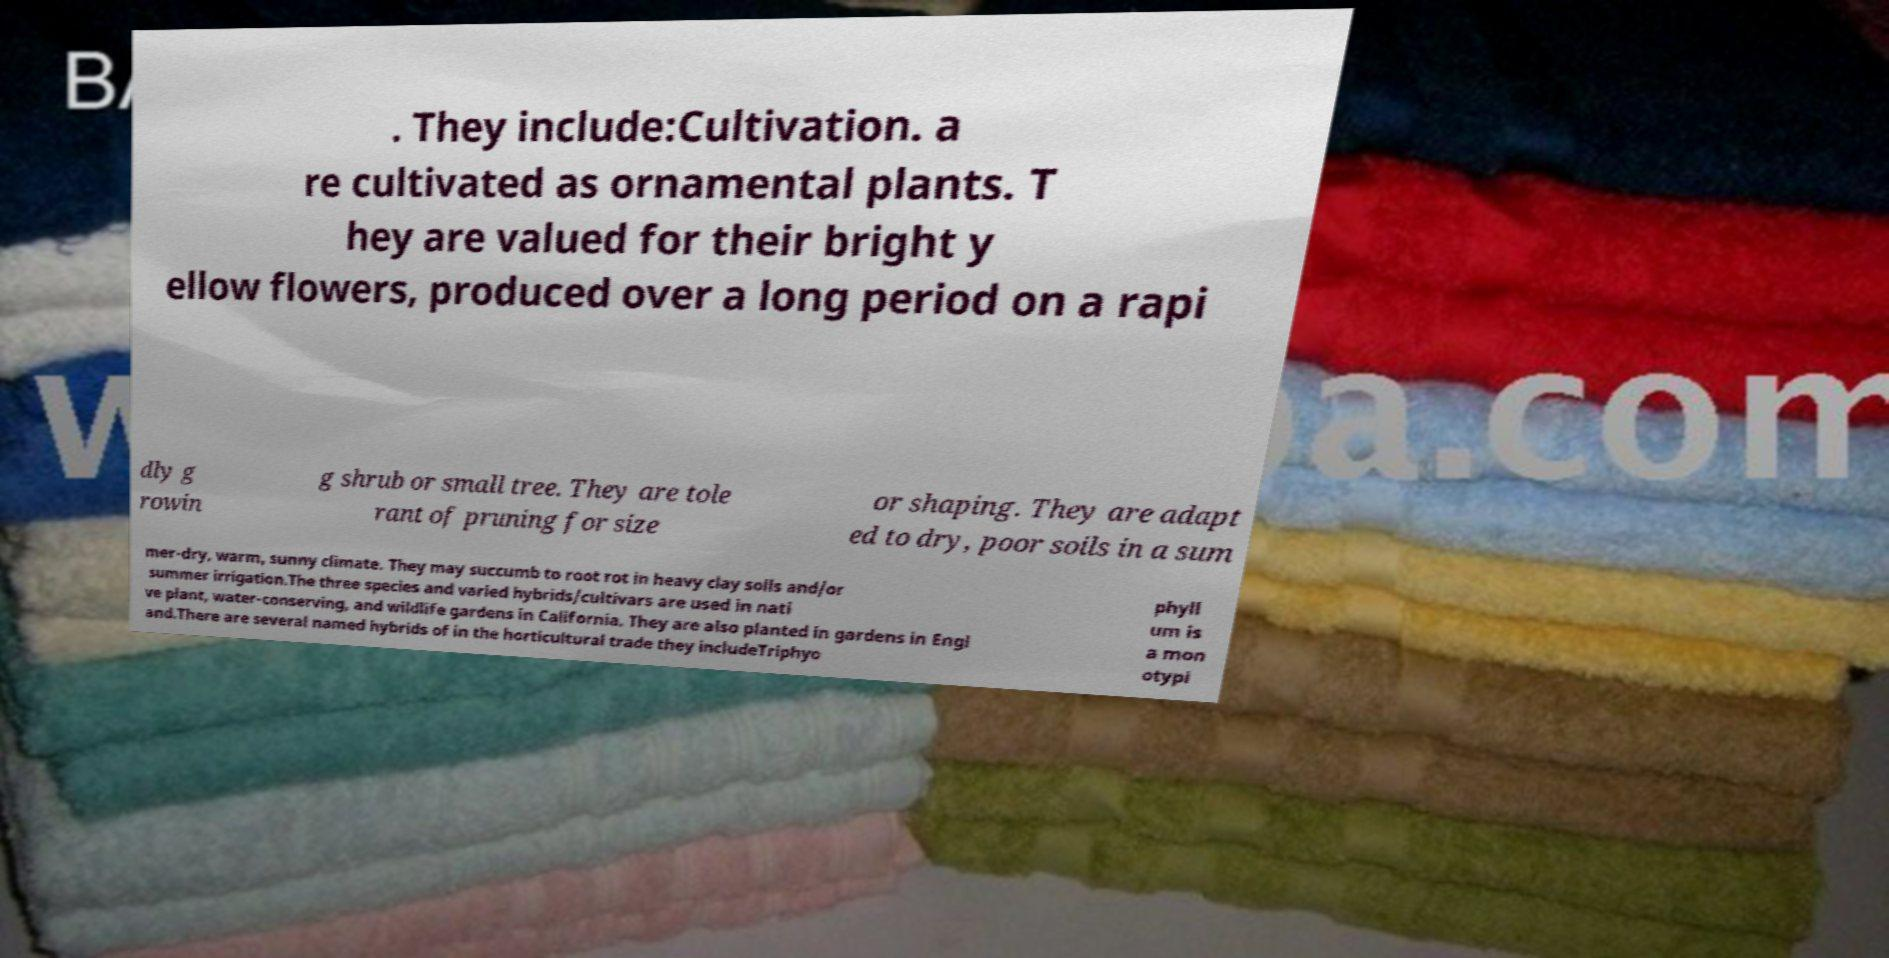What messages or text are displayed in this image? I need them in a readable, typed format. . They include:Cultivation. a re cultivated as ornamental plants. T hey are valued for their bright y ellow flowers, produced over a long period on a rapi dly g rowin g shrub or small tree. They are tole rant of pruning for size or shaping. They are adapt ed to dry, poor soils in a sum mer-dry, warm, sunny climate. They may succumb to root rot in heavy clay soils and/or summer irrigation.The three species and varied hybrids/cultivars are used in nati ve plant, water-conserving, and wildlife gardens in California. They are also planted in gardens in Engl and.There are several named hybrids of in the horticultural trade they includeTriphyo phyll um is a mon otypi 